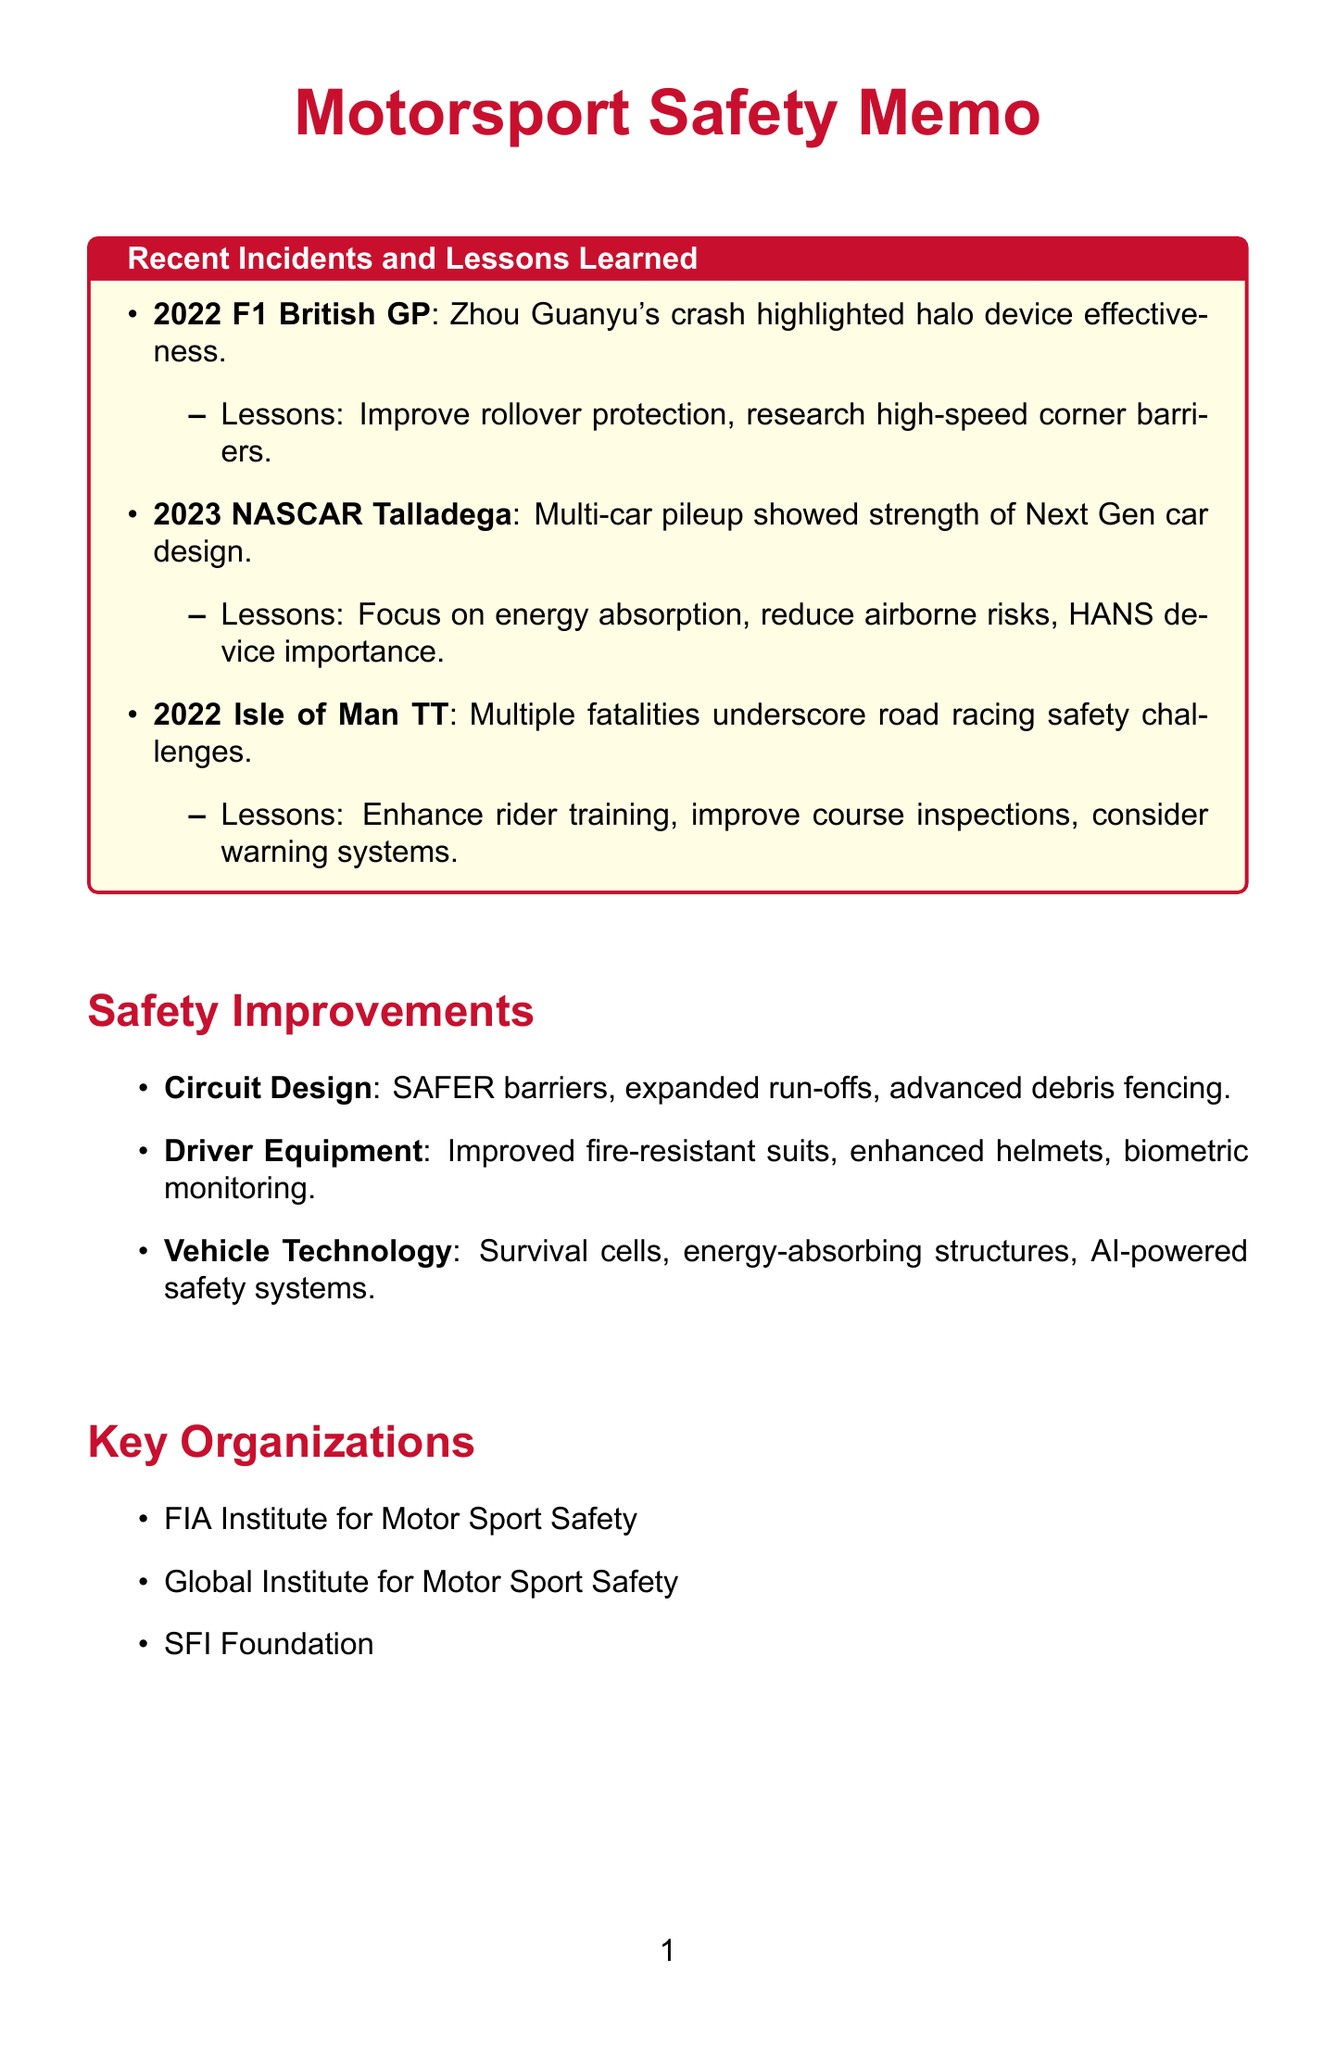What incident occurred at the 2022 Formula 1 British Grand Prix? The incident at the 2022 Formula 1 British Grand Prix was Zhou Guanyu's high-speed crash.
Answer: Zhou Guanyu's high-speed crash What are the lessons learned from the 2023 NASCAR Cup Series incident? The lessons learned from the 2023 NASCAR Cup Series incident include the importance of energy-absorbing structures, reducing airborne risks, and the effectiveness of HANS devices.
Answer: Energy-absorbing structures, reducing airborne risks, HANS devices How many fatalities occurred during the 2022 Isle of Man TT? The 2022 Isle of Man TT event saw five rider fatalities, which illustrates the ongoing safety challenges in road racing events.
Answer: Five What improvements are suggested for circuit design? Suggested improvements for circuit design include the implementation of high-tech barrier systems like SAFER barriers, expansion of run-off areas, and installation of advanced debris fencing.
Answer: SAFER barriers, run-off areas, advanced debris fencing Which organization focuses on research and development of safety technologies in motorsport? The organization that focuses on research and development of safety technologies in motorsport is the FIA Institute for Motor Sport Safety.
Answer: FIA Institute for Motor Sport Safety What is a key focus area for training in motorsport safety? A key focus area for training in motorsport safety is proper use and maintenance of personal safety equipment.
Answer: Proper use and maintenance of personal safety equipment What type of barriers should be implemented according to the safety improvements? According to the safety improvements, high-tech barrier systems such as SAFER barriers should be implemented.
Answer: SAFER barriers Which event involved a multi-car pileup? The event that involved a multi-car pileup was the 2023 NASCAR Cup Series at Talladega.
Answer: 2023 NASCAR Cup Series at Talladega 